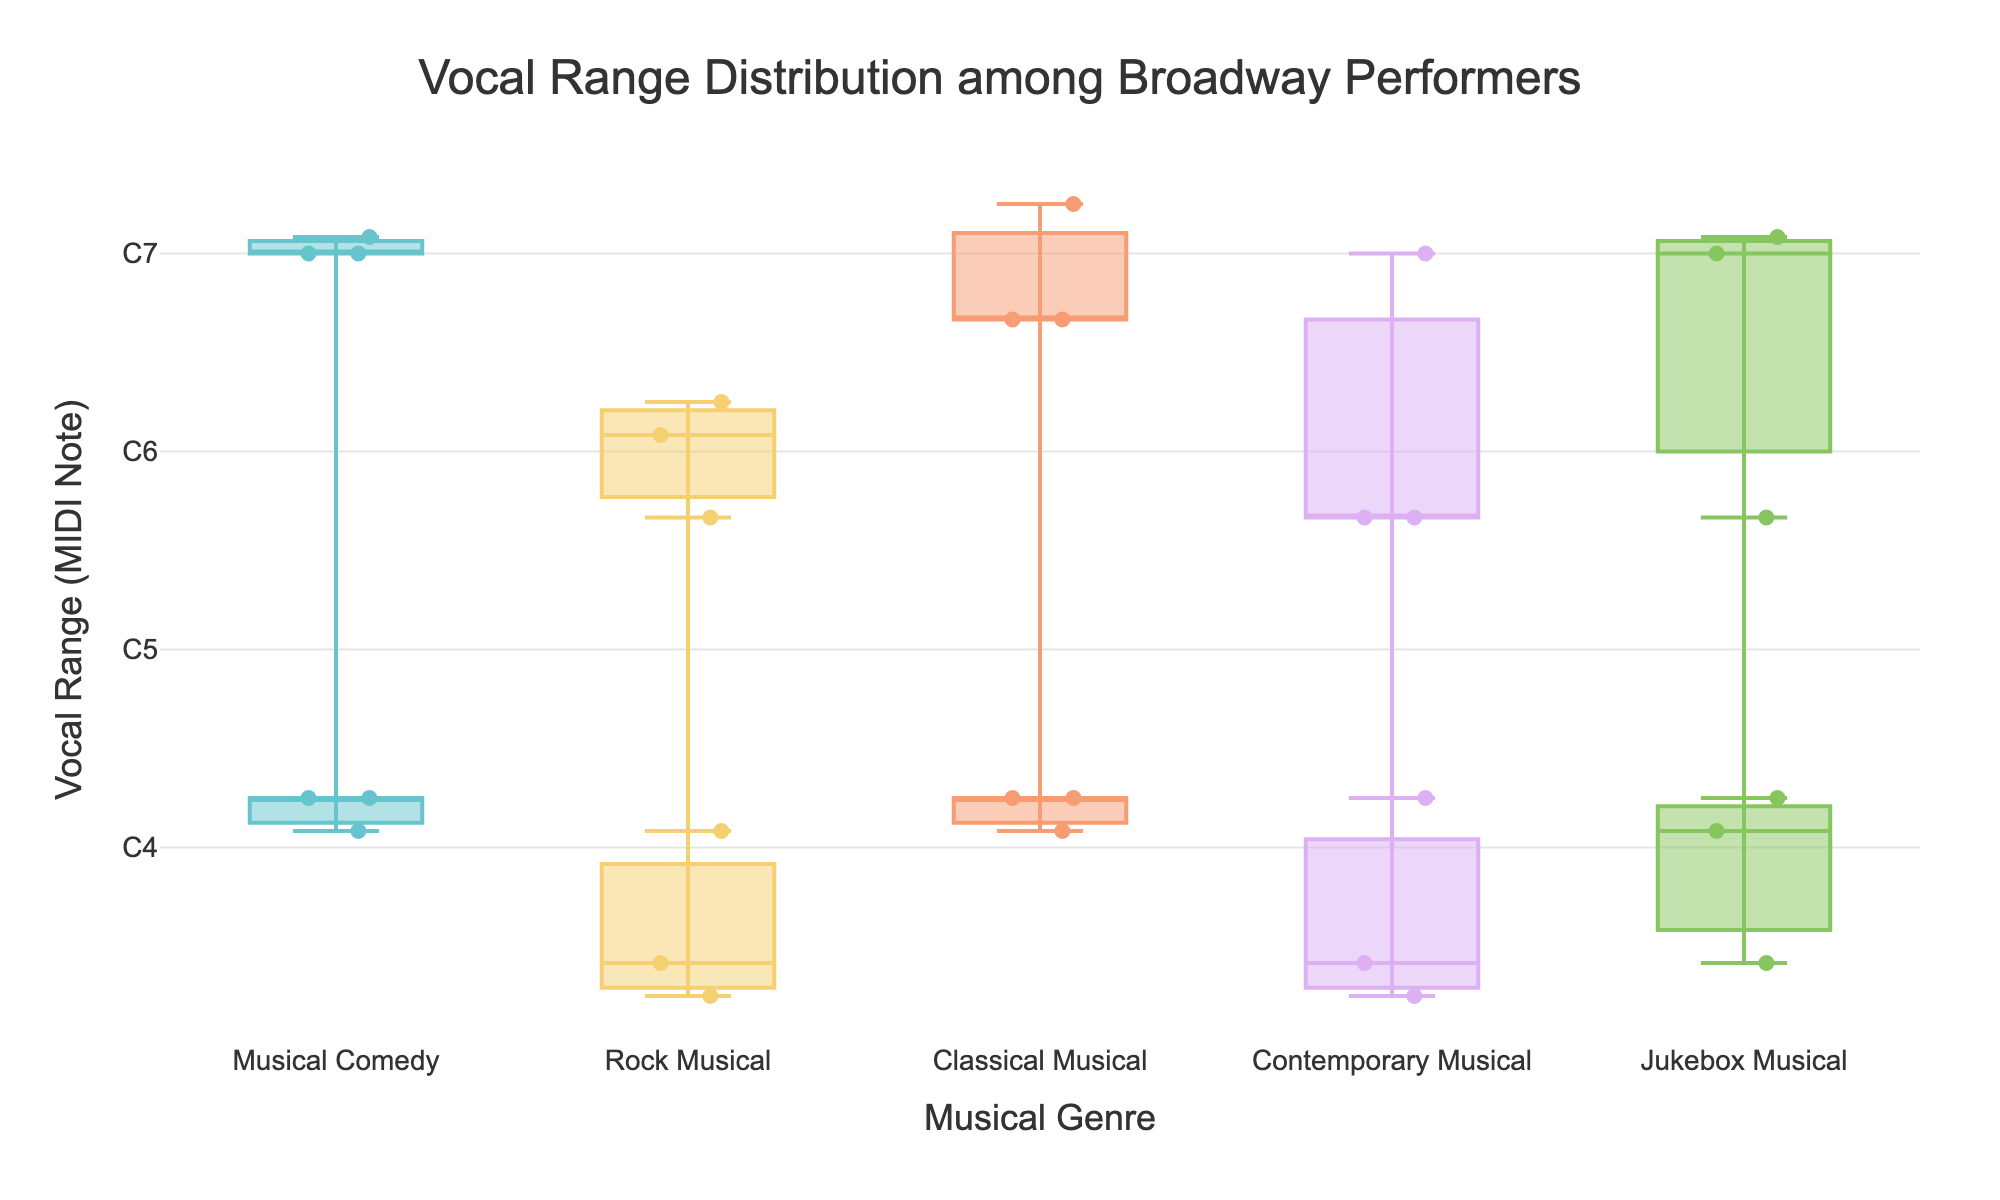Which performer has the widest vocal range? To determine the performer with the widest vocal range, look for the performer whose vertical line representing their vocal range spans the most significant distance on the y-axis (MIDI note values). Kristin Chenoweth in the "Musical Comedy" genre has a wide range from G3 (55) to F6 (89), which is 34 MIDI notes wide.
Answer: Kristin Chenoweth How do the vocal ranges of "Rock Musical" performers compare with "Contemporary Musical" performers? Compare the vertical spans of vocal ranges for "Rock Musical" against those for "Contemporary Musical" on the y-axis (MIDI notes). "Rock Musical" has ranges from G2 (43) to G5 (79), while "Contemporary Musical" ranges from G2 (43) to E6 (88), with wider ranges on the higher end in contemporary.
Answer: Contemporary Musical performers generally have higher ranges How many musical genres are presented in the figure? Count the unique genres listed along the x-axis. The figure shows Musical Comedy, Rock Musical, Classical Musical, Contemporary Musical, and Jukebox Musical.
Answer: 5 Which genre generally has the highest soprano ranges? Identify the genre with the highest points on the y-axis for the top of each vocal range. Classical Musical examples like Sierra Boggess (G6) and Audra McDonald (C6) are among the highest points, indicating that classical has the highest soprano ranges.
Answer: Classical Musical What is the highest vocal note in the entire dataset and which performer achieves it? Look for the highest point on the y-axis and identify the corresponding performer. Sierra Boggess from the "Classical Musical" genre has the highest note at G6 (91).
Answer: Sierra Boggess Calculate the average highest note for "Jukebox Musical" performers. Identify each highest note in the "Jukebox Musical" genre and average them. The highest notes are F6 (89), E6 (88), and C5 (76). The average of these is (89 + 88 + 76)/3 = 253/3 = 84.33 (approximately E6 using standard MIDI note names).
Answer: E6 Which genre has the largest spread in vocal ranges? Assess the maximum and minimum MIDI note values for each genre and see which has the largest difference between high and low points. "Musical Comedy" has performers with wide ranges (G3 to F6, E6), indicating a large spread.
Answer: Musical Comedy Does any performer in "Contemporary Musical" genre overlap in vocal range with someone in "Rock Musical"? Compare the spans of vocal ranges in "Contemporary Musical" with those in "Rock Musical". Ben Platt (A2-C5) and Leslie Odom Jr. (G2-C5) overlap with Adam Pascal (G2-C5), Anthony Rapp (A2-G5).
Answer: Yes What is the typical vocal range for "Musical Comedy" performers based on the figure? Look for the range of vertical lines in the "Musical Comedy" genre. The typical range seems to be around G3 to E6.
Answer: G3 to E6 Which genres have the lowest starting notes in the performers' ranges? Identify the genres with the lowest points on the y-axis for the starting notes. "Rock Musical" (G2) and "Contemporary Musical" (G2, A2) have some of the lowest starting notes.
Answer: Rock Musical and Contemporary Musical 